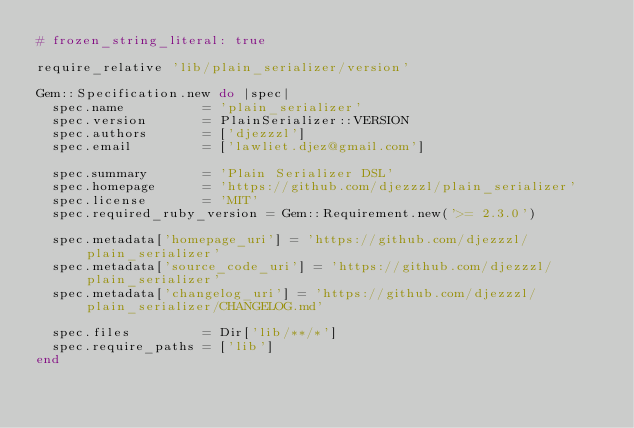<code> <loc_0><loc_0><loc_500><loc_500><_Ruby_># frozen_string_literal: true

require_relative 'lib/plain_serializer/version'

Gem::Specification.new do |spec|
  spec.name          = 'plain_serializer'
  spec.version       = PlainSerializer::VERSION
  spec.authors       = ['djezzzl']
  spec.email         = ['lawliet.djez@gmail.com']

  spec.summary       = 'Plain Serializer DSL'
  spec.homepage      = 'https://github.com/djezzzl/plain_serializer'
  spec.license       = 'MIT'
  spec.required_ruby_version = Gem::Requirement.new('>= 2.3.0')

  spec.metadata['homepage_uri'] = 'https://github.com/djezzzl/plain_serializer'
  spec.metadata['source_code_uri'] = 'https://github.com/djezzzl/plain_serializer'
  spec.metadata['changelog_uri'] = 'https://github.com/djezzzl/plain_serializer/CHANGELOG.md'

  spec.files         = Dir['lib/**/*']
  spec.require_paths = ['lib']
end
</code> 